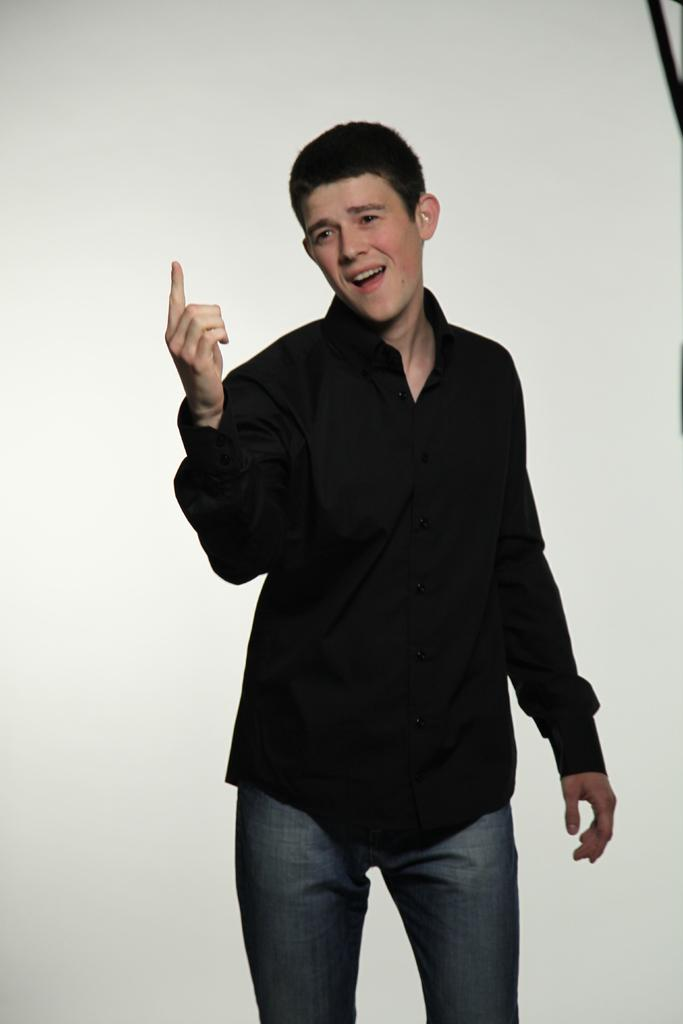Who is present in the image? There is a man in the image. What is the man doing in the image? The man is standing in the image. What color is the man's shirt? The man is wearing a black shirt in the image. What color are the man's pants? The man is wearing blue jeans in the image. What color is the background of the image? The background of the image is white. What type of marble is the man holding in the image? There is no marble present in the image; the man is not holding anything. 